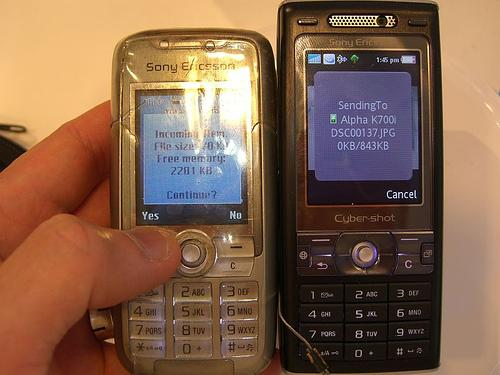What is the most prominent word displayed on the black cellphone? The most prominent word on the black phone is "Cybershot." Identify the two main objects in the image and describe their colors. There are two cellphones in the image, one is a silver Sony Ericsson phone and the other is a black Sony Ericsson Cybershot phone. What is the unique visual feature on the silver phone's screen? The silver phone's screen displays the word "Continue" along with a question mark. Provide an appropriate context on where this image might appear, based on the given information. This photo will soon appear in a magazine. Provide both the sentiment and detailed description of the image based on the given information. The image has a rather vivid sentiment and features two cellphones, silver and black Sony Ericsson phones, held in a person's hand with visible small buttons, a bright screen, and a black pouch. Mention a fact about the authorship or history of the photo, as depicted within the image. According to the information in the image, Zander Zane owns the photo. 